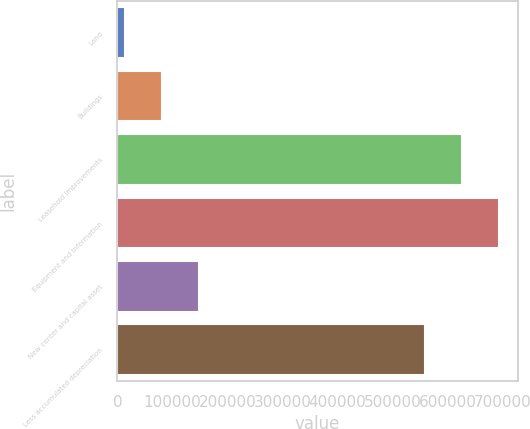Convert chart. <chart><loc_0><loc_0><loc_500><loc_500><bar_chart><fcel>Land<fcel>Buildings<fcel>Leasehold improvements<fcel>Equipment and information<fcel>New center and capital asset<fcel>Less accumulated depreciation<nl><fcel>13593<fcel>80876.3<fcel>626004<fcel>693288<fcel>148160<fcel>558721<nl></chart> 